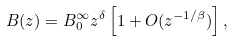Convert formula to latex. <formula><loc_0><loc_0><loc_500><loc_500>B ( z ) = B _ { 0 } ^ { \infty } z ^ { \delta } \left [ 1 + O ( z ^ { - 1 / \beta } ) \right ] ,</formula> 